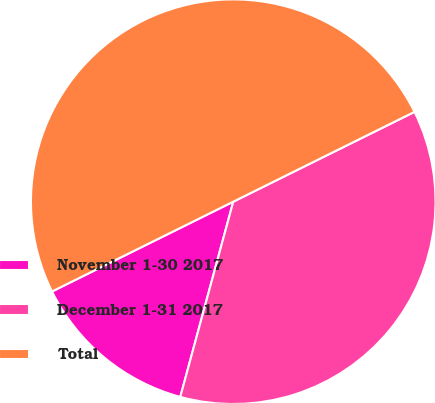Convert chart to OTSL. <chart><loc_0><loc_0><loc_500><loc_500><pie_chart><fcel>November 1-30 2017<fcel>December 1-31 2017<fcel>Total<nl><fcel>13.46%<fcel>36.54%<fcel>50.0%<nl></chart> 